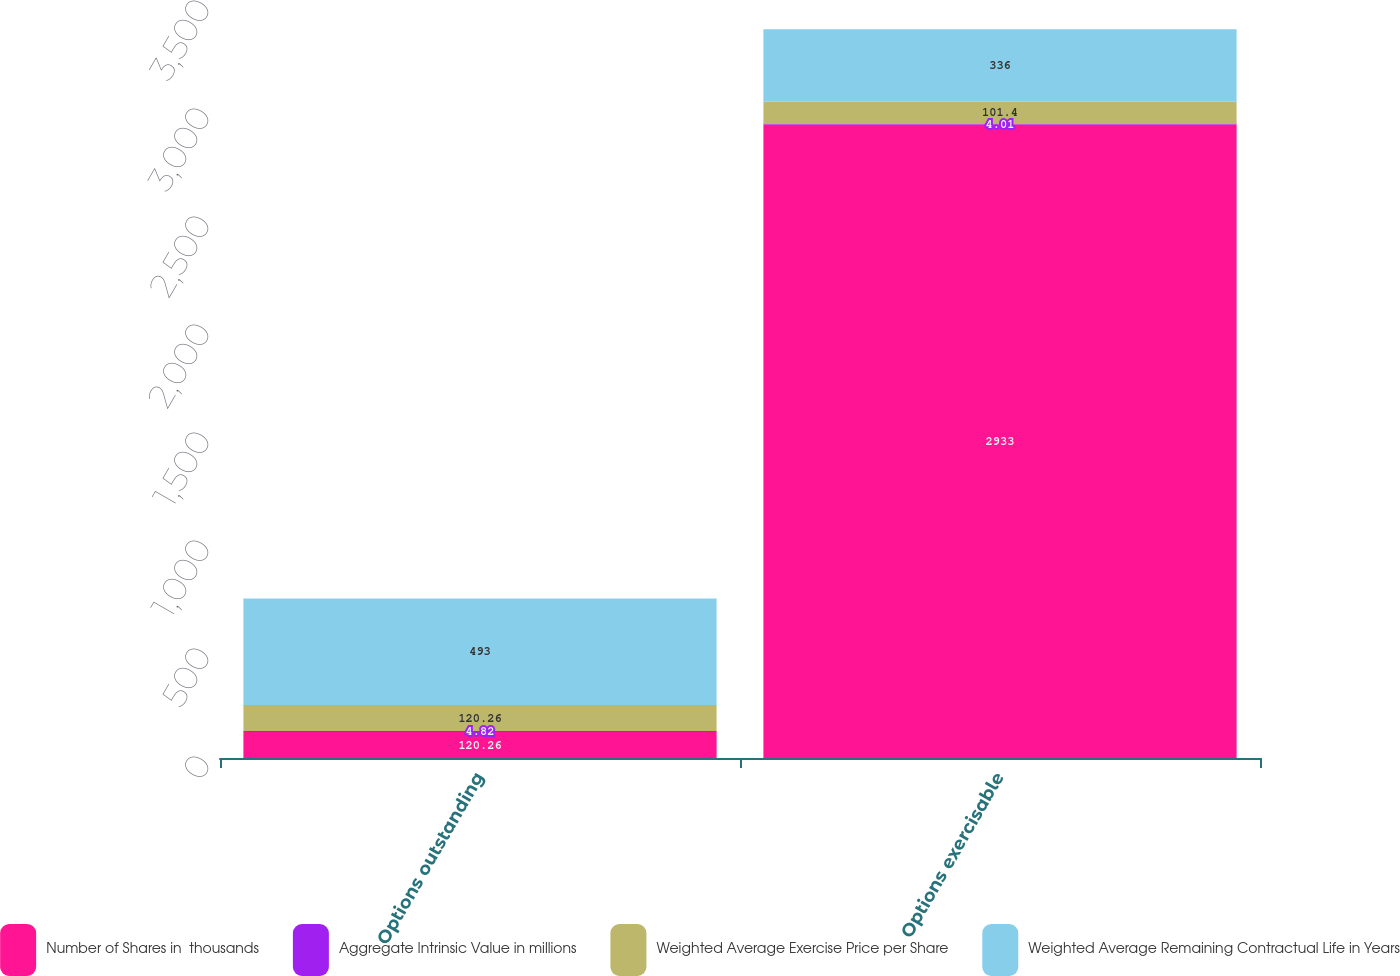Convert chart to OTSL. <chart><loc_0><loc_0><loc_500><loc_500><stacked_bar_chart><ecel><fcel>Options outstanding<fcel>Options exercisable<nl><fcel>Number of Shares in  thousands<fcel>120.26<fcel>2933<nl><fcel>Aggregate Intrinsic Value in millions<fcel>4.82<fcel>4.01<nl><fcel>Weighted Average Exercise Price per Share<fcel>120.26<fcel>101.4<nl><fcel>Weighted Average Remaining Contractual Life in Years<fcel>493<fcel>336<nl></chart> 